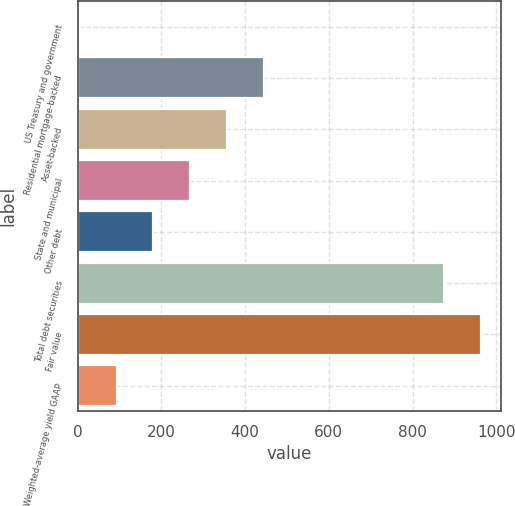Convert chart. <chart><loc_0><loc_0><loc_500><loc_500><bar_chart><fcel>US Treasury and government<fcel>Residential mortgage-backed<fcel>Asset-backed<fcel>State and municipal<fcel>Other debt<fcel>Total debt securities<fcel>Fair value<fcel>Weighted-average yield GAAP<nl><fcel>5<fcel>444<fcel>356.2<fcel>268.4<fcel>180.6<fcel>876<fcel>963.8<fcel>92.8<nl></chart> 